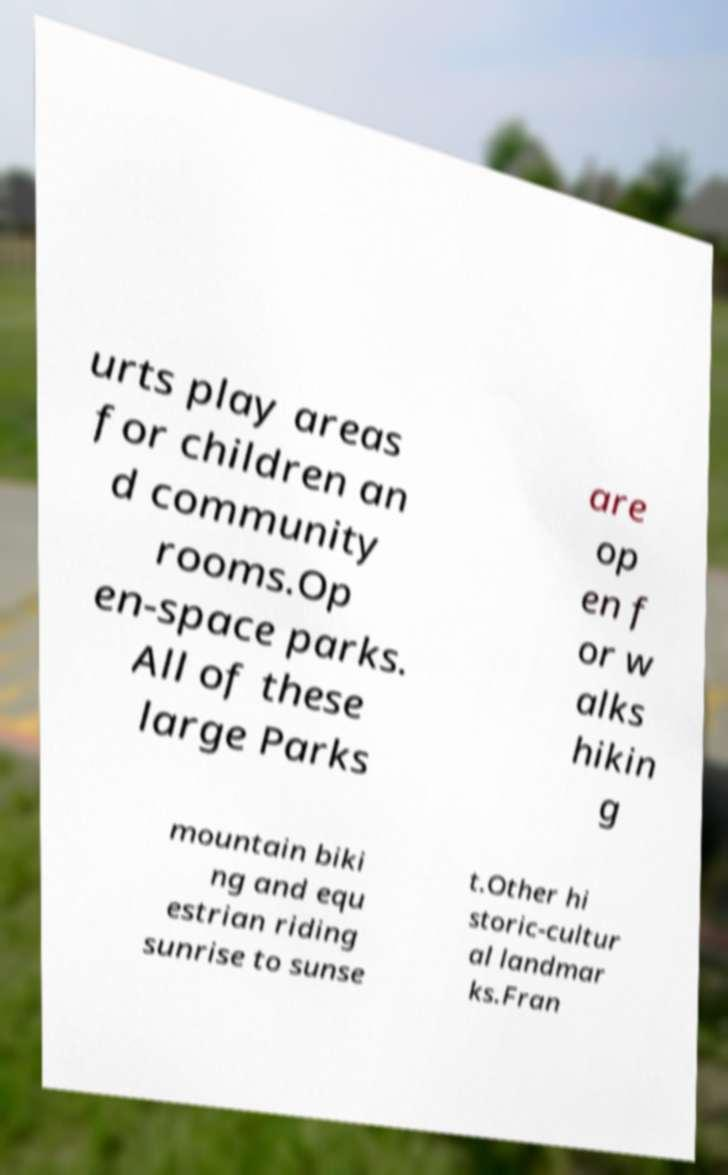Please identify and transcribe the text found in this image. urts play areas for children an d community rooms.Op en-space parks. All of these large Parks are op en f or w alks hikin g mountain biki ng and equ estrian riding sunrise to sunse t.Other hi storic-cultur al landmar ks.Fran 